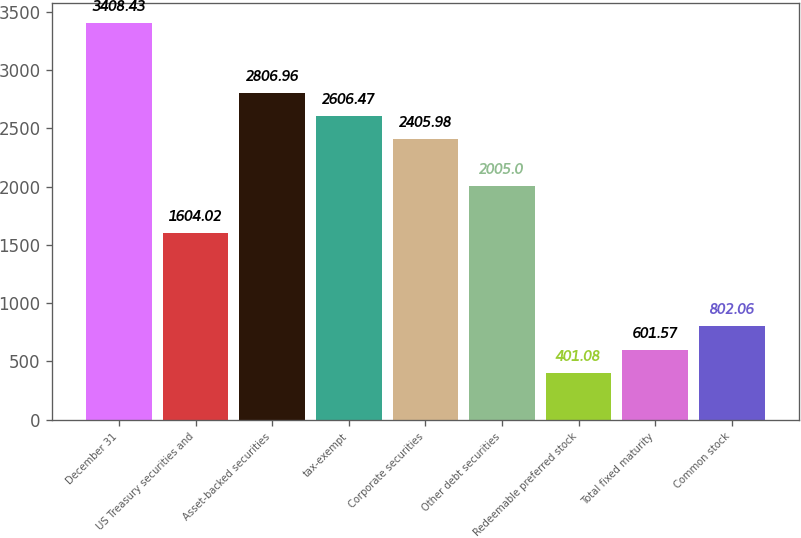Convert chart to OTSL. <chart><loc_0><loc_0><loc_500><loc_500><bar_chart><fcel>December 31<fcel>US Treasury securities and<fcel>Asset-backed securities<fcel>tax-exempt<fcel>Corporate securities<fcel>Other debt securities<fcel>Redeemable preferred stock<fcel>Total fixed maturity<fcel>Common stock<nl><fcel>3408.43<fcel>1604.02<fcel>2806.96<fcel>2606.47<fcel>2405.98<fcel>2005<fcel>401.08<fcel>601.57<fcel>802.06<nl></chart> 